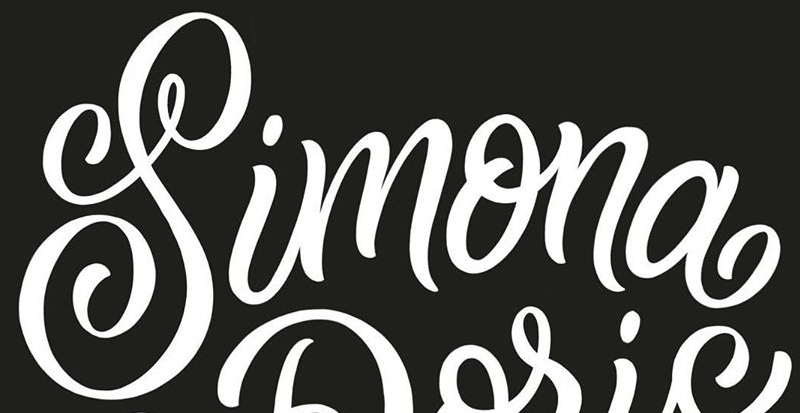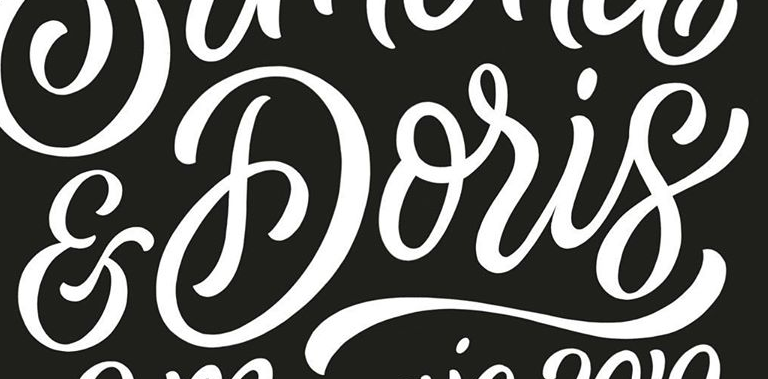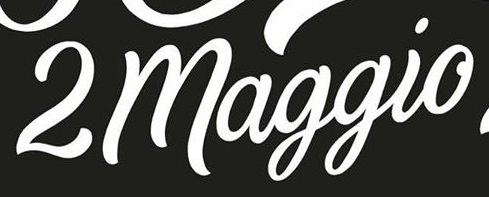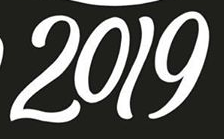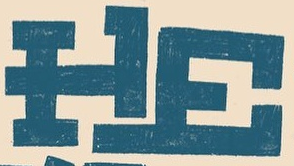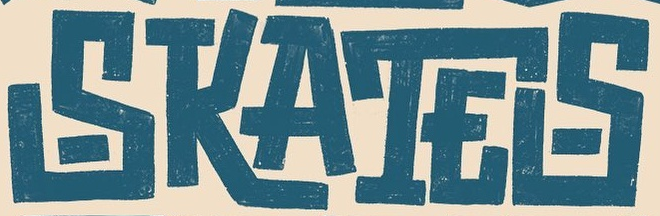What text is displayed in these images sequentially, separated by a semicolon? Simona; &Doris; 2maggio; 2019; HE; SKATES 